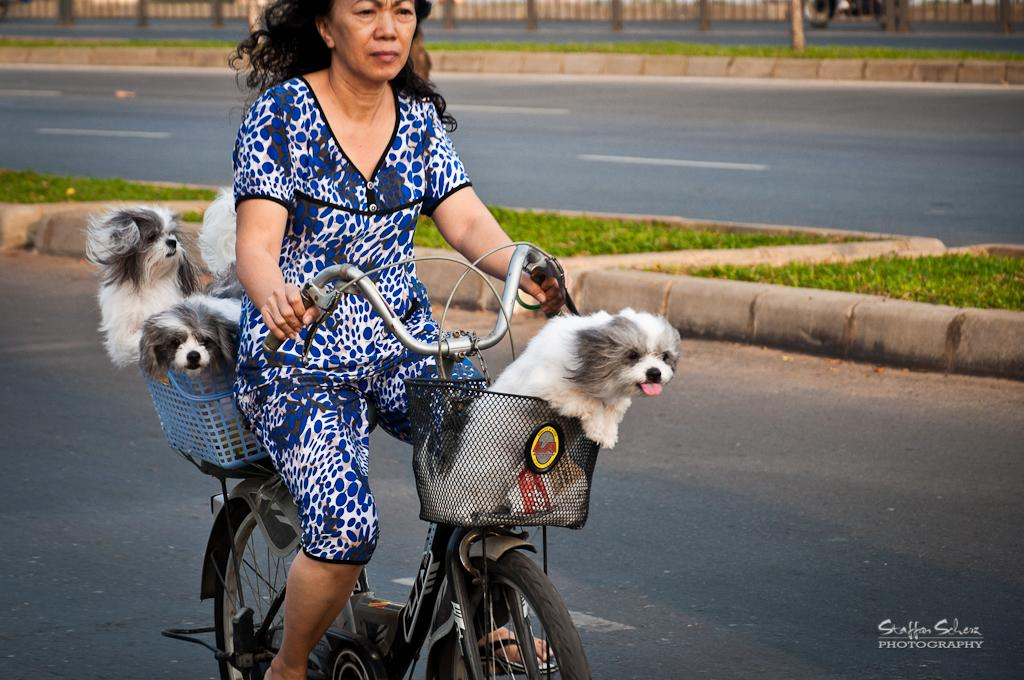What is the woman doing in the image? The woman is riding a bicycle in the image. Are there any animals with the woman? Yes, there are dogs with the woman. What type of terrain is visible in the image? There is grass visible in the image. What type of path is the woman riding on? There is a road in the image. What type of cheese is the woman eating while riding the bicycle in the image? There is no cheese present in the image, and the woman is not eating anything while riding the bicycle. 